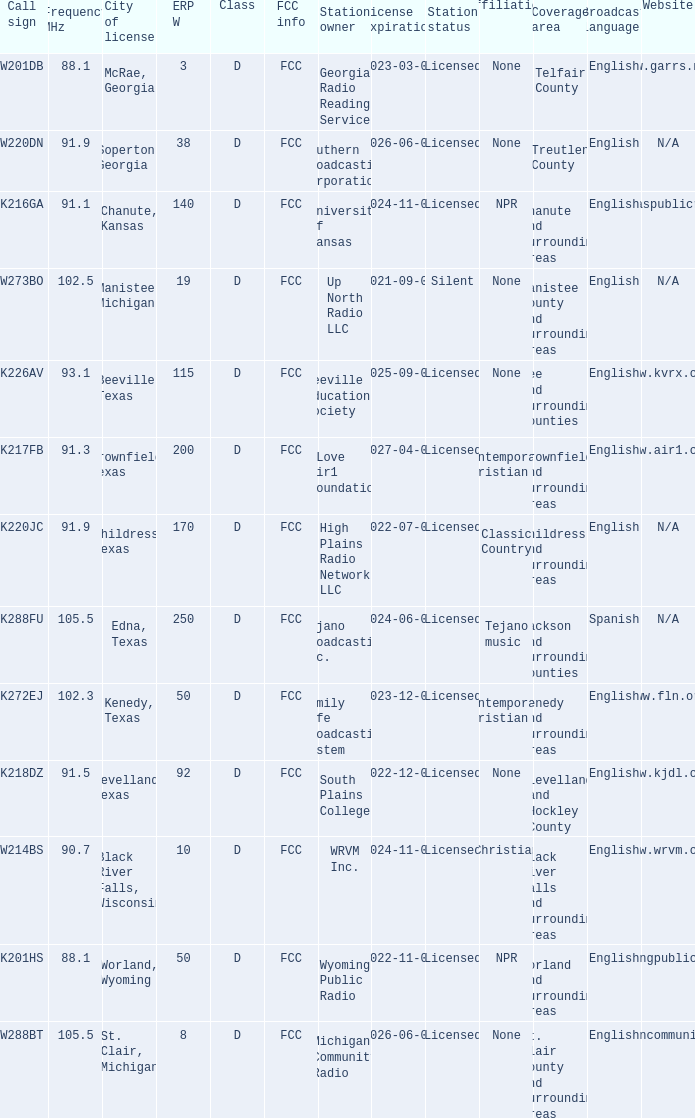What is City of License, when ERP W is greater than 3, and when Call Sign is K218DZ? Levelland, Texas. Could you help me parse every detail presented in this table? {'header': ['Call sign', 'Frequency MHz', 'City of license', 'ERP W', 'Class', 'FCC info', 'Station owner', 'License expiration', 'Station status', 'Affiliation', 'Coverage area', 'Broadcast language', 'Website'], 'rows': [['W201DB', '88.1', 'McRae, Georgia', '3', 'D', 'FCC', 'Georgia Radio Reading Service', '2023-03-01', 'Licensed', 'None', 'Telfair County', 'English', 'www.garrs.net'], ['W220DN', '91.9', 'Soperton, Georgia', '38', 'D', 'FCC', 'Southern Broadcasting Corporation', '2026-06-01', 'Licensed', 'None', 'Treutlen County', 'English', 'N/A'], ['K216GA', '91.1', 'Chanute, Kansas', '140', 'D', 'FCC', 'University of Kansas', '2024-11-01', 'Licensed', 'NPR', 'Chanute and surrounding areas', 'English', 'www.kansaspublicradio.org'], ['W273BO', '102.5', 'Manistee, Michigan', '19', 'D', 'FCC', 'Up North Radio LLC', '2021-09-01', 'Silent', 'None', 'Manistee County and surrounding areas', 'English', 'N/A'], ['K226AV', '93.1', 'Beeville, Texas', '115', 'D', 'FCC', 'Beeville Educational Society', '2025-09-01', 'Licensed', 'None', 'Bee and surrounding counties', 'English', 'www.kvrx.org'], ['K217FB', '91.3', 'Brownfield, Texas', '200', 'D', 'FCC', 'KLove Air1 Foundation', '2027-04-01', 'Licensed', 'Contemporary Christian', 'Brownfield and surrounding areas', 'English', 'www.air1.com'], ['K220JC', '91.9', 'Childress, Texas', '170', 'D', 'FCC', 'High Plains Radio Network LLC', '2022-07-01', 'Licensed', 'Classic Country', 'Childress and surrounding areas', 'English', 'N/A'], ['K288FU', '105.5', 'Edna, Texas', '250', 'D', 'FCC', 'Tejano Broadcasting Inc.', '2024-06-01', 'Licensed', 'Tejano music', 'Jackson and surrounding counties', 'Spanish', 'N/A'], ['K272EJ', '102.3', 'Kenedy, Texas', '50', 'D', 'FCC', 'Family Life Broadcasting System', '2023-12-01', 'Licensed', 'Contemporary Christian', 'Kenedy and surrounding areas', 'English', 'www.fln.org'], ['K218DZ', '91.5', 'Levelland, Texas', '92', 'D', 'FCC', 'South Plains College', '2022-12-01', 'Licensed', 'None', 'Levelland and Hockley County', 'English', 'www.kjdl.org'], ['W214BS', '90.7', 'Black River Falls, Wisconsin', '10', 'D', 'FCC', 'WRVM Inc.', '2024-11-01', 'Licensed', 'Christian', 'Black River Falls and surrounding areas', 'English', 'www.wrvm.org'], ['K201HS', '88.1', 'Worland, Wyoming', '50', 'D', 'FCC', 'Wyoming Public Radio', '2022-11-01', 'Licensed', 'NPR', 'Worland and surrounding areas', 'English', 'www.wyomingpublicmedia.org'], ['W288BT', '105.5', 'St. Clair, Michigan', '8', 'D', 'FCC', 'Michigan Community Radio', '2026-06-01', 'Licensed', 'None', 'St. Clair County and surrounding areas', 'English', 'www.michigancommunityradio.org']]} 